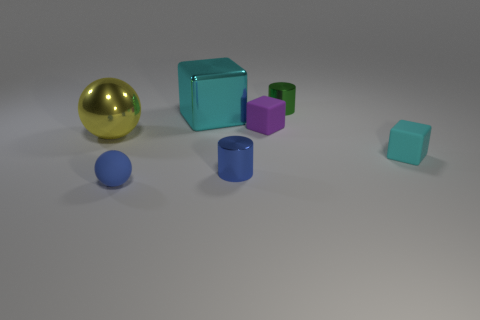What time of day does the lighting in the scene suggest? The neutral lighting in the scene doesn't strongly suggest a particular time of day. It appears to be soft, diffused lighting that could be reminiscent of a cloudy day or an indoor setting with ambient light. 